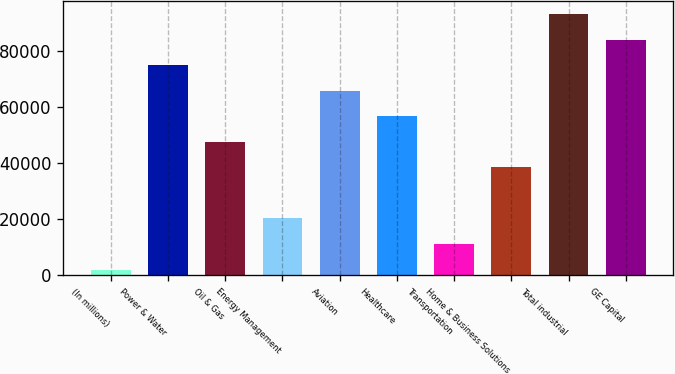<chart> <loc_0><loc_0><loc_500><loc_500><bar_chart><fcel>(In millions)<fcel>Power & Water<fcel>Oil & Gas<fcel>Energy Management<fcel>Aviation<fcel>Healthcare<fcel>Transportation<fcel>Home & Business Solutions<fcel>Total industrial<fcel>GE Capital<nl><fcel>2011<fcel>74872.6<fcel>47549.5<fcel>20226.4<fcel>65764.9<fcel>56657.2<fcel>11118.7<fcel>38441.8<fcel>93088<fcel>83980.3<nl></chart> 